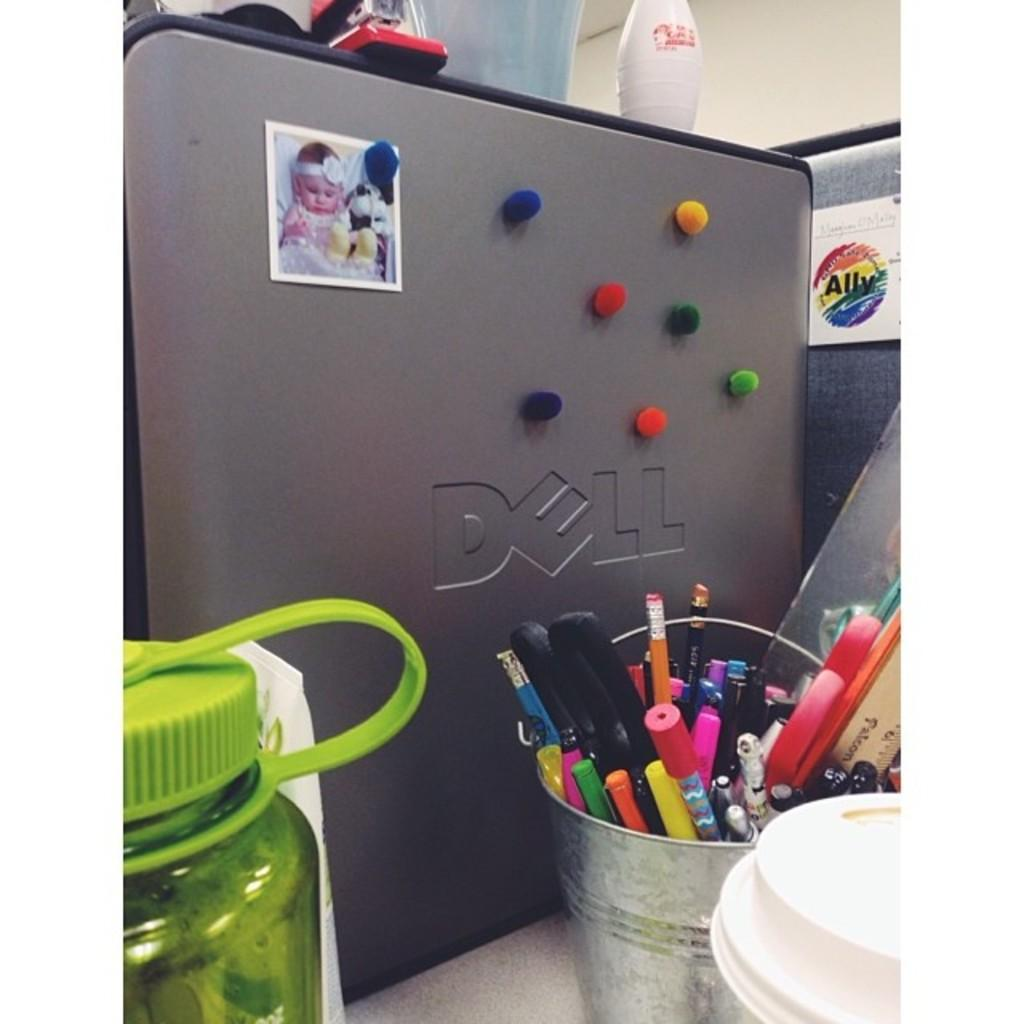<image>
Offer a succinct explanation of the picture presented. A Dell computer with a tin container full of pens sitting next to it. 